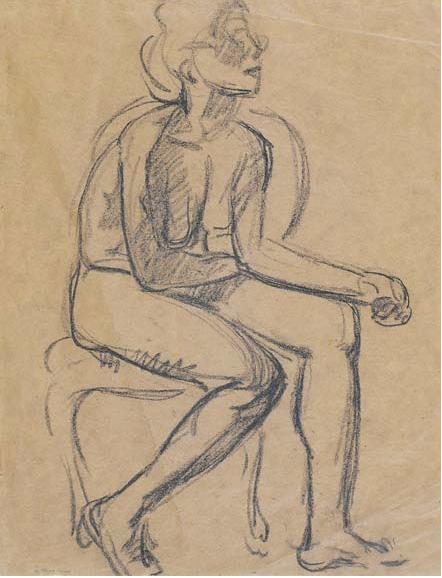Describe the emotions evoked by this artwork. The artwork evokes a sense of calm contemplation and introspection. The seated figure, with their relaxed posture and averted gaze, suggests a quiet moment of reflection. The loose, gestural style of the sketch imparts a sense of freedom and fluidity, capturing the natural, unguarded state of the human form. The simplicity of the background and the monochromatic palette further enhance the introspective mood, inviting the viewer to ponder the inner world of the subject. Overall, the piece communicates a serene and timeless quality, making the viewer feel as though they are glimpsing a private, introspective moment frozen in time. If this figure could speak, what do you think they would say? If this figure could speak, they might say, "I am lost in my thoughts, pondering the profundities of life and the paths I have taken." Their expression and relaxed posture suggest a deep, personal contemplation, perhaps wrestling with a decision or reminiscing about past experiences. They might share their reflections on the passage of time, the nature of existence, or the complexities of human emotions. Given the introspective mood of the sketch, their words would likely be thoughtful and reflective, offering a glimpse into their inner world. Imagine this scene as part of a larger story. What might be happening just outside the frame? Just outside the frame, the scene might expand into a quiet artist's studio filled with various sketches and artistic tools. Papers and easels are scattered around, with other incomplete works hinting at the artist's ongoing exploration of the human form. Perhaps a window on the right allows soft, diffused light to fill the room, casting gentle shadows that create a serene and introspective atmosphere. There might also be other figures in the room, possibly friends or fellow artists engaged in their own creative endeavors, adding layers to the narrative of shared creativity and introspection. This framed scene could be a snapshot in a larger story of an artist's journey through exploration, creation, and reflection. 